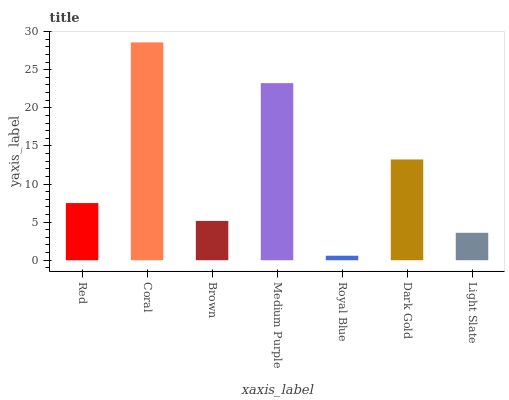Is Royal Blue the minimum?
Answer yes or no. Yes. Is Coral the maximum?
Answer yes or no. Yes. Is Brown the minimum?
Answer yes or no. No. Is Brown the maximum?
Answer yes or no. No. Is Coral greater than Brown?
Answer yes or no. Yes. Is Brown less than Coral?
Answer yes or no. Yes. Is Brown greater than Coral?
Answer yes or no. No. Is Coral less than Brown?
Answer yes or no. No. Is Red the high median?
Answer yes or no. Yes. Is Red the low median?
Answer yes or no. Yes. Is Brown the high median?
Answer yes or no. No. Is Brown the low median?
Answer yes or no. No. 